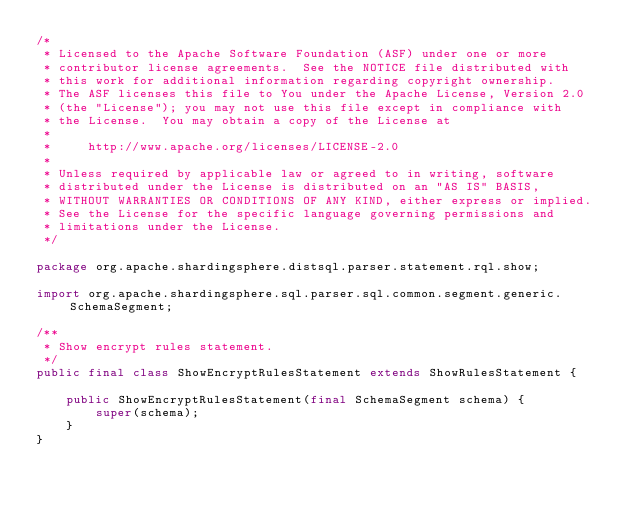<code> <loc_0><loc_0><loc_500><loc_500><_Java_>/*
 * Licensed to the Apache Software Foundation (ASF) under one or more
 * contributor license agreements.  See the NOTICE file distributed with
 * this work for additional information regarding copyright ownership.
 * The ASF licenses this file to You under the Apache License, Version 2.0
 * (the "License"); you may not use this file except in compliance with
 * the License.  You may obtain a copy of the License at
 *
 *     http://www.apache.org/licenses/LICENSE-2.0
 *
 * Unless required by applicable law or agreed to in writing, software
 * distributed under the License is distributed on an "AS IS" BASIS,
 * WITHOUT WARRANTIES OR CONDITIONS OF ANY KIND, either express or implied.
 * See the License for the specific language governing permissions and
 * limitations under the License.
 */

package org.apache.shardingsphere.distsql.parser.statement.rql.show;

import org.apache.shardingsphere.sql.parser.sql.common.segment.generic.SchemaSegment;

/**
 * Show encrypt rules statement.
 */
public final class ShowEncryptRulesStatement extends ShowRulesStatement {

    public ShowEncryptRulesStatement(final SchemaSegment schema) {
        super(schema);
    }
}
</code> 